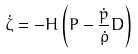Convert formula to latex. <formula><loc_0><loc_0><loc_500><loc_500>\dot { \zeta } = - H \left ( P - \frac { \dot { p } } { \dot { \rho } } D \right )</formula> 